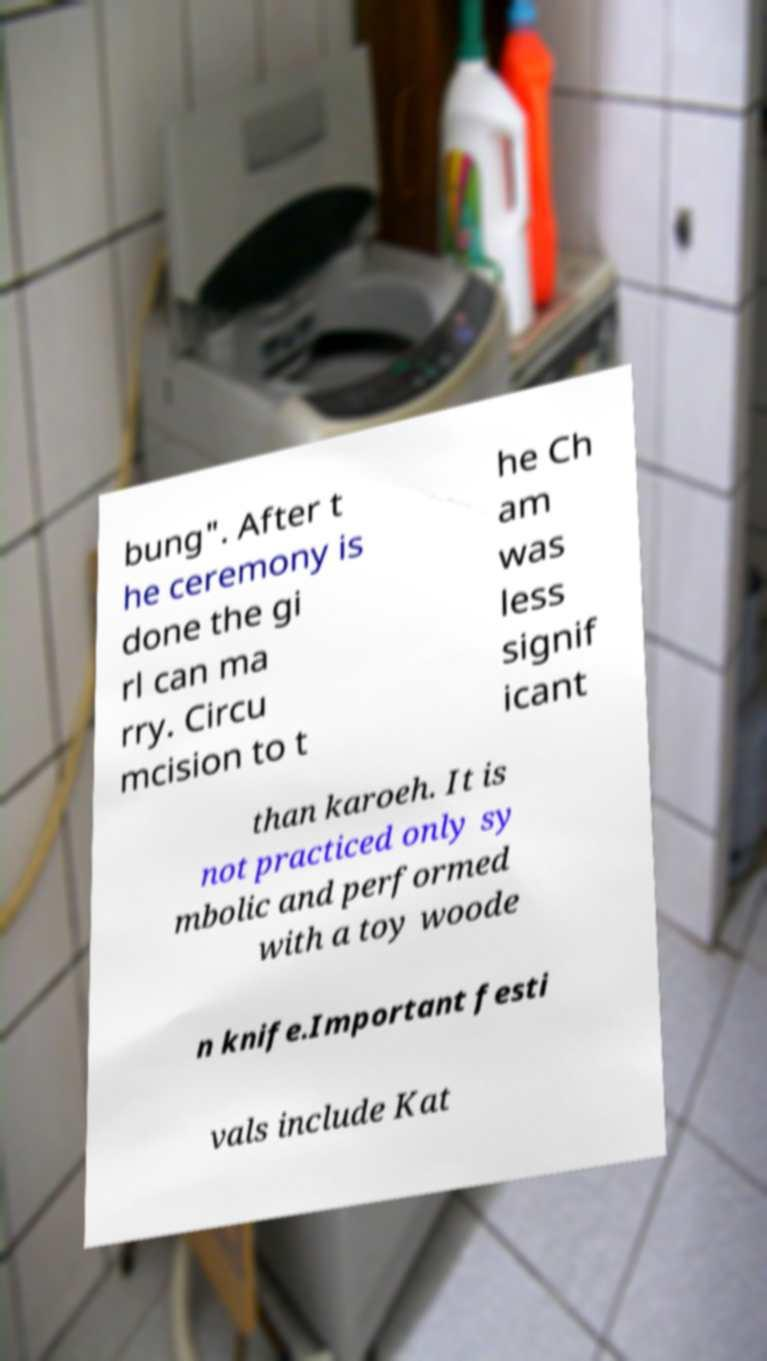Please identify and transcribe the text found in this image. bung". After t he ceremony is done the gi rl can ma rry. Circu mcision to t he Ch am was less signif icant than karoeh. It is not practiced only sy mbolic and performed with a toy woode n knife.Important festi vals include Kat 